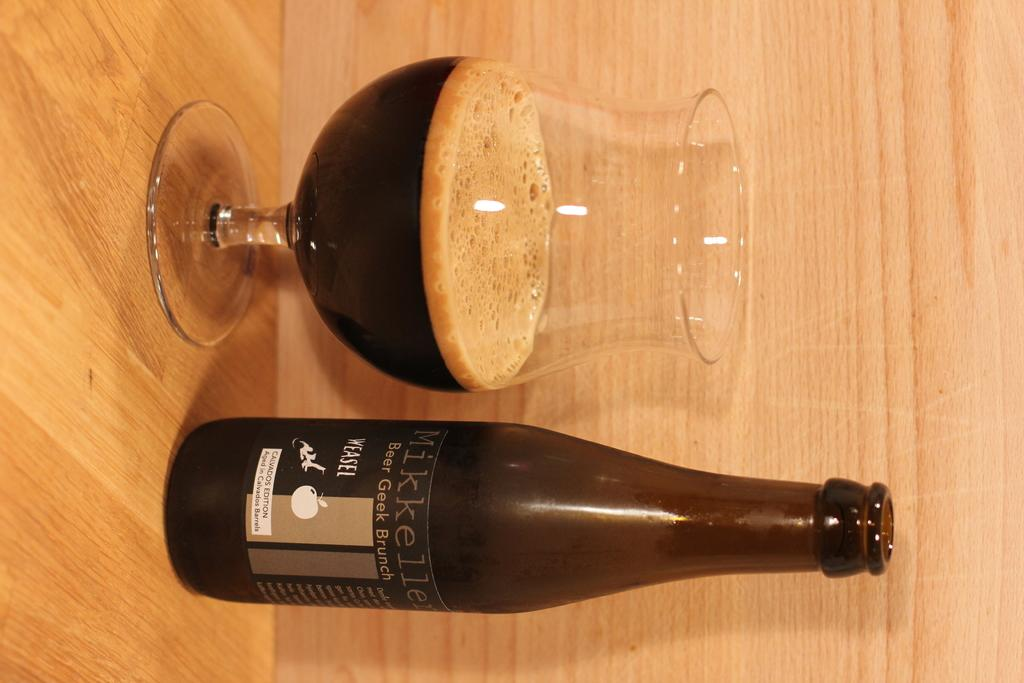<image>
Offer a succinct explanation of the picture presented. A bottle of Mikkeller beer poured into a glass. 